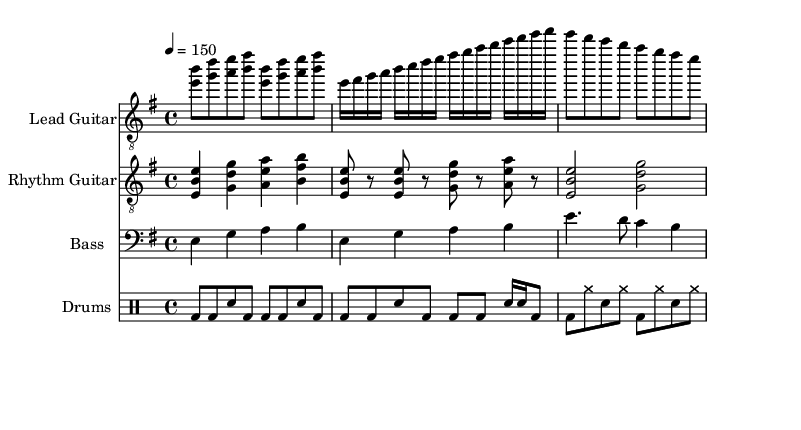What is the key signature of this music? The key signature is E minor, which has one sharp (F#). This can be identified from the key signature indicated at the beginning of the music sheet.
Answer: E minor What is the time signature of this music? The time signature is 4/4, which means there are four beats in each measure and indicates how the music is structured rhythmically. This is shown at the beginning of the sheet music.
Answer: 4/4 What is the tempo marking for this piece? The tempo marking is 4 = 150, which indicates the speed at which the piece should be played, specifically that there are 150 beats per minute. This is found in the tempo indication at the start of the score.
Answer: 150 How many measures are in the intro section? The intro section consists of 2 measures, as indicated by the repeated phrases shown in the lead guitar part. Each of the phrases corresponds to one measure, and they repeat twice.
Answer: 2 What type of rhythm is predominantly used in the verse section? The verse section predominantly uses eighth notes, which are indicated by the notation in the rhythm guitar part, and create a driving, energetic feel typical in melodic death metal.
Answer: Eighth notes What instrument plays the primary melodic lines? The lead guitar plays the primary melodic lines, as seen in the treble staff where the melody is written. This is characteristic of melodic death metal, emphasizing the guitar's role in melody.
Answer: Lead guitar How does the rhythm in the chorus differ from the verse? The rhythm in the chorus is composed of longer note values, primarily using half notes, which contrasts with the faster pace of eighth notes in the verse, creating a shift in intensity. This can be analyzed by comparing the rhythm notations in both sections.
Answer: Longer notes 